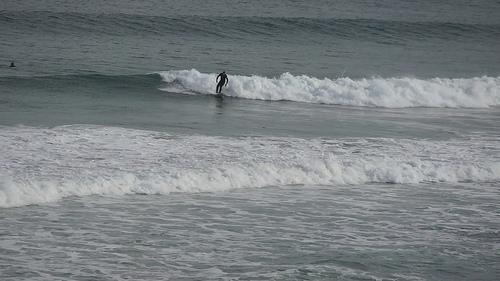How many waves are in this picture?
Give a very brief answer. 2. 